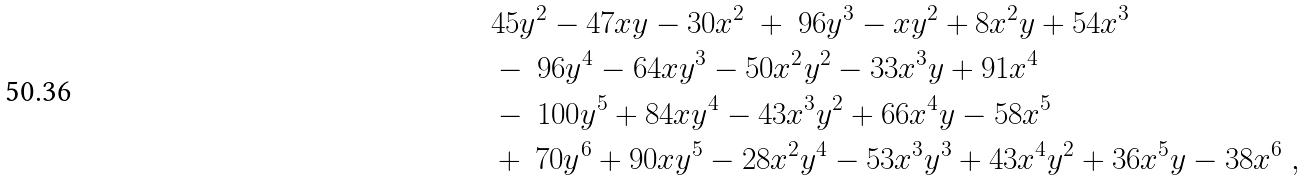<formula> <loc_0><loc_0><loc_500><loc_500>& 4 5 y ^ { 2 } - 4 7 x y - 3 0 x ^ { 2 } \ + \ 9 6 y ^ { 3 } - x y ^ { 2 } + 8 x ^ { 2 } y + 5 4 x ^ { 3 } \\ & - \ 9 6 y ^ { 4 } - 6 4 x y ^ { 3 } - 5 0 x ^ { 2 } y ^ { 2 } - 3 3 x ^ { 3 } y + 9 1 x ^ { 4 } \\ & - \ 1 0 0 y ^ { 5 } + 8 4 x y ^ { 4 } - 4 3 x ^ { 3 } y ^ { 2 } + 6 6 x ^ { 4 } y - 5 8 x ^ { 5 } \\ & + \ 7 0 y ^ { 6 } + 9 0 x y ^ { 5 } - 2 8 x ^ { 2 } y ^ { 4 } - 5 3 x ^ { 3 } y ^ { 3 } + 4 3 x ^ { 4 } y ^ { 2 } + 3 6 x ^ { 5 } y - 3 8 x ^ { 6 } \ ,</formula> 